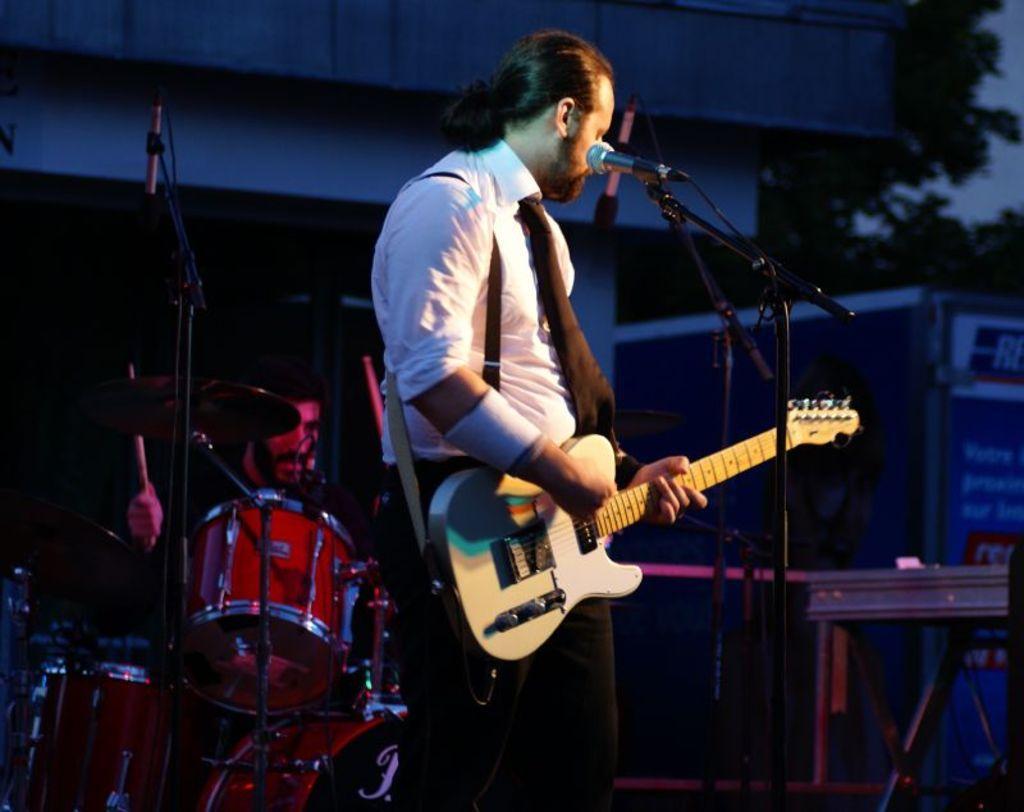Describe this image in one or two sentences. Image has a person standing by wearing a white shirt and tie holding a guitar. Before him there is a mike stand. At the left side there is a person at the backside of musical instrument. He is playing this musical instrument. At the background there are few trees and a house 